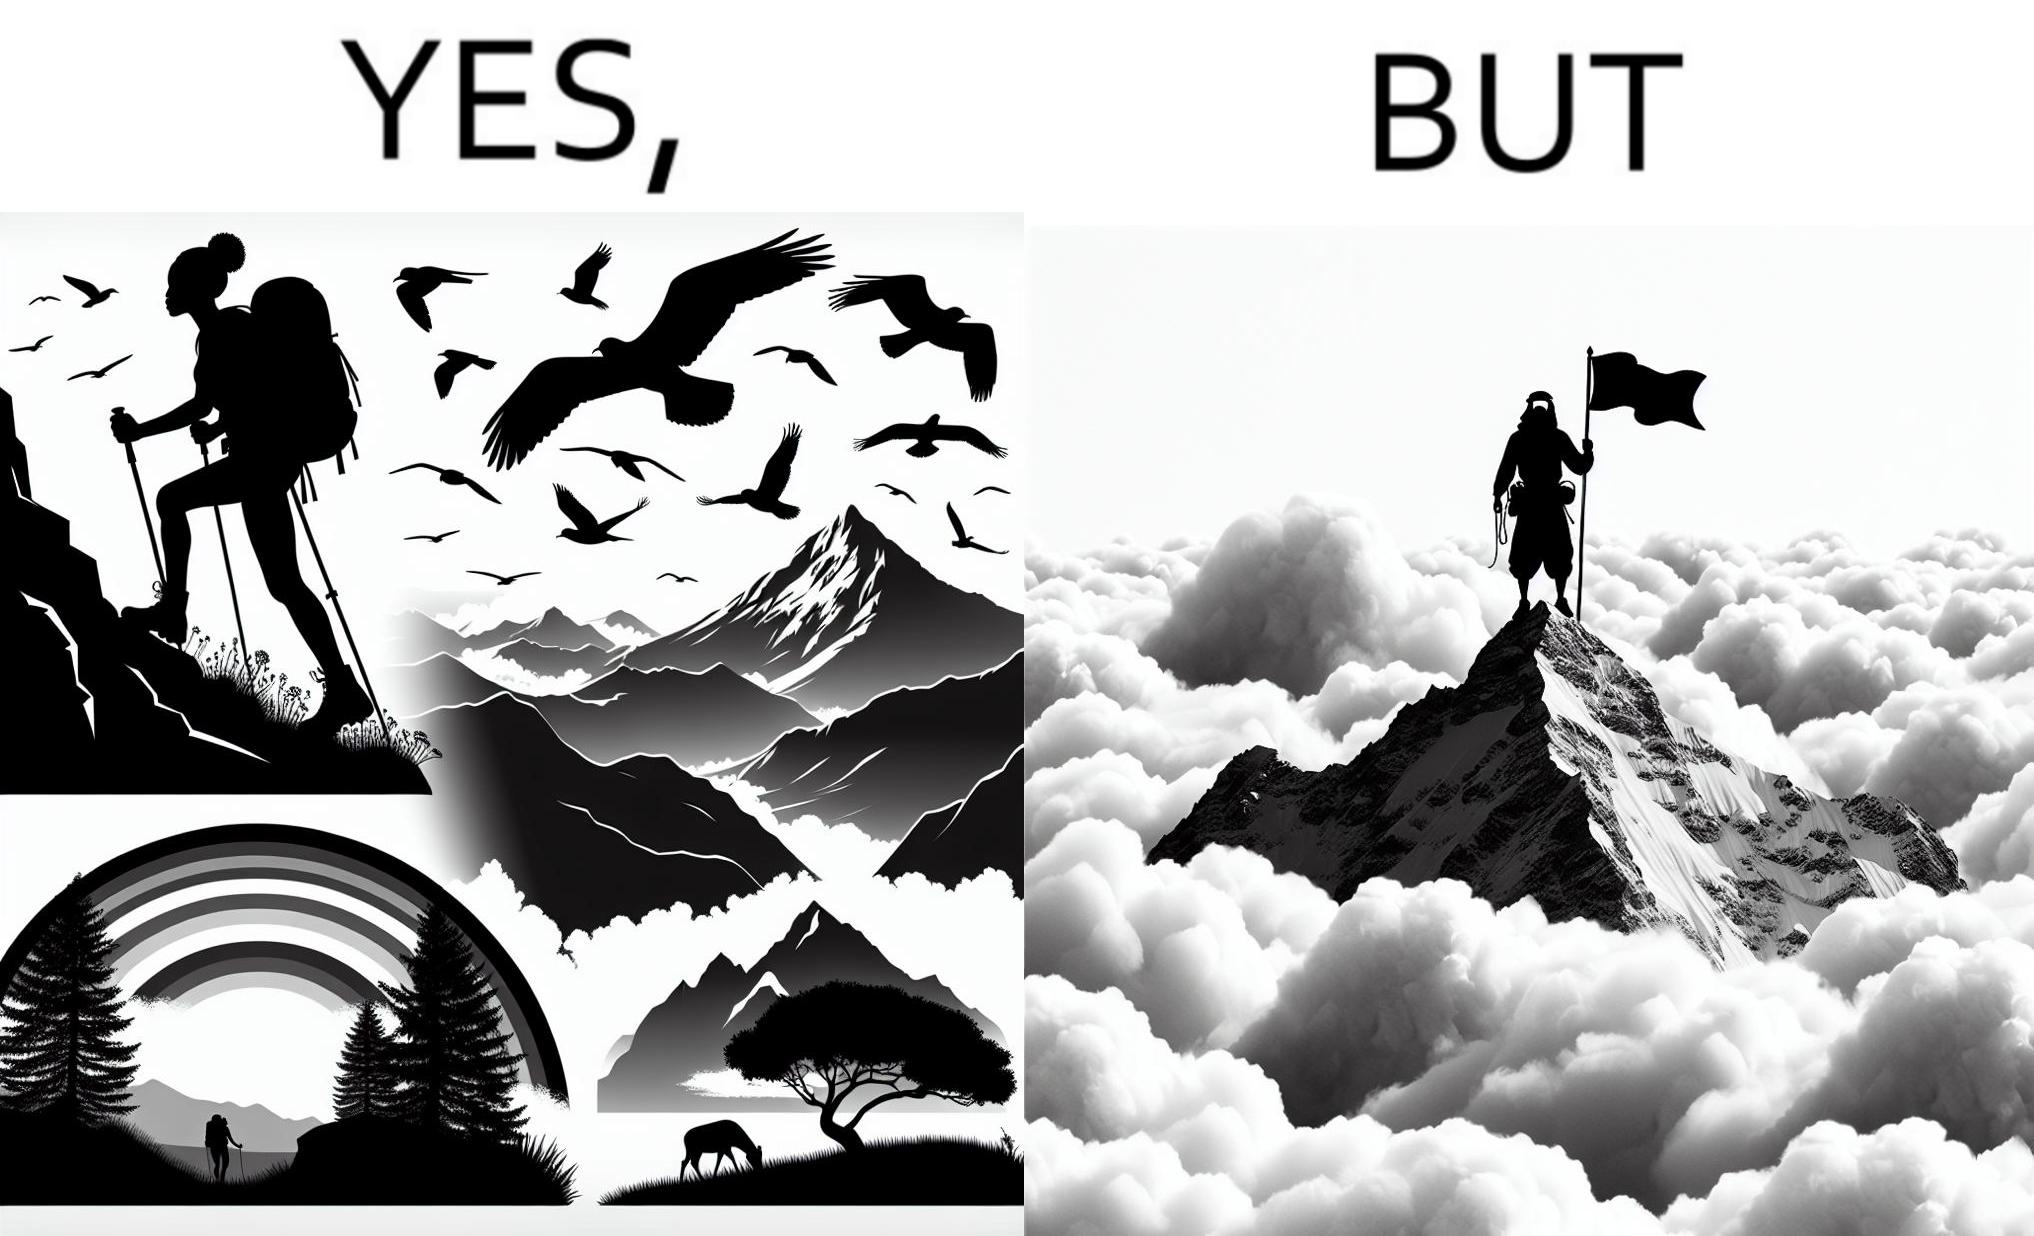What is shown in the left half versus the right half of this image? In the left part of the image: a mountaineer climbing up the mountain, enjoying the view, birds are flying, rainbow is visible In the right part of the image: a mountaineer is at the peak of the mountain but nothing is visible due to clouds 